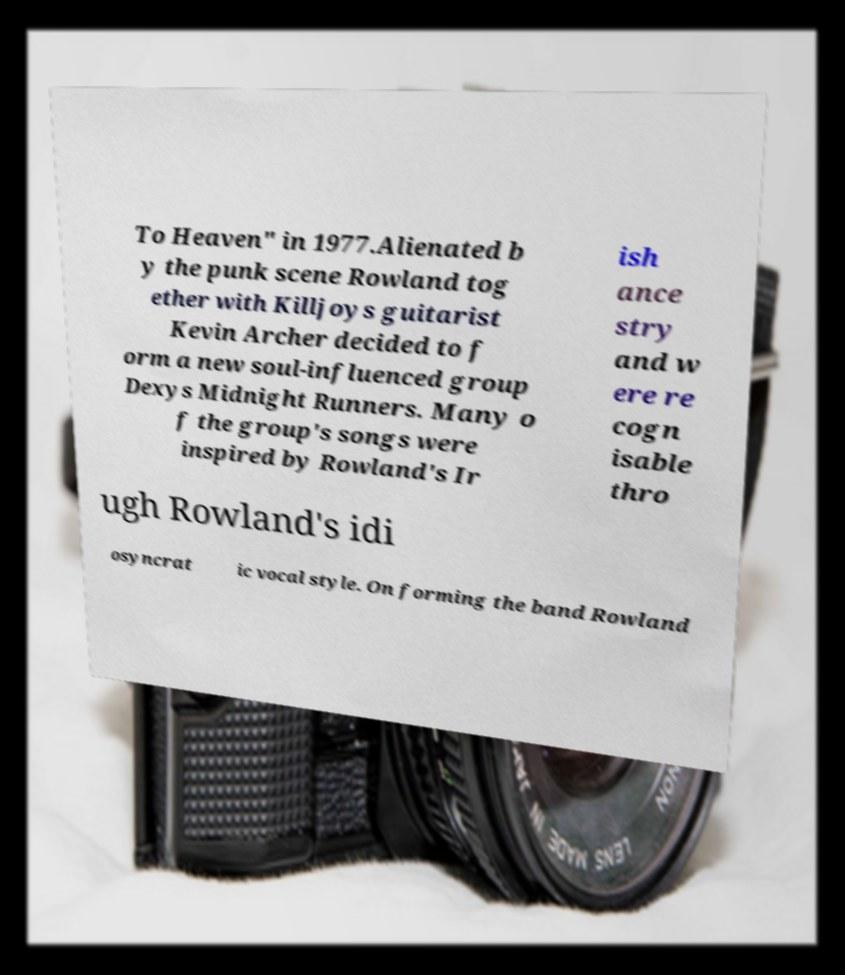Can you accurately transcribe the text from the provided image for me? To Heaven" in 1977.Alienated b y the punk scene Rowland tog ether with Killjoys guitarist Kevin Archer decided to f orm a new soul-influenced group Dexys Midnight Runners. Many o f the group's songs were inspired by Rowland's Ir ish ance stry and w ere re cogn isable thro ugh Rowland's idi osyncrat ic vocal style. On forming the band Rowland 